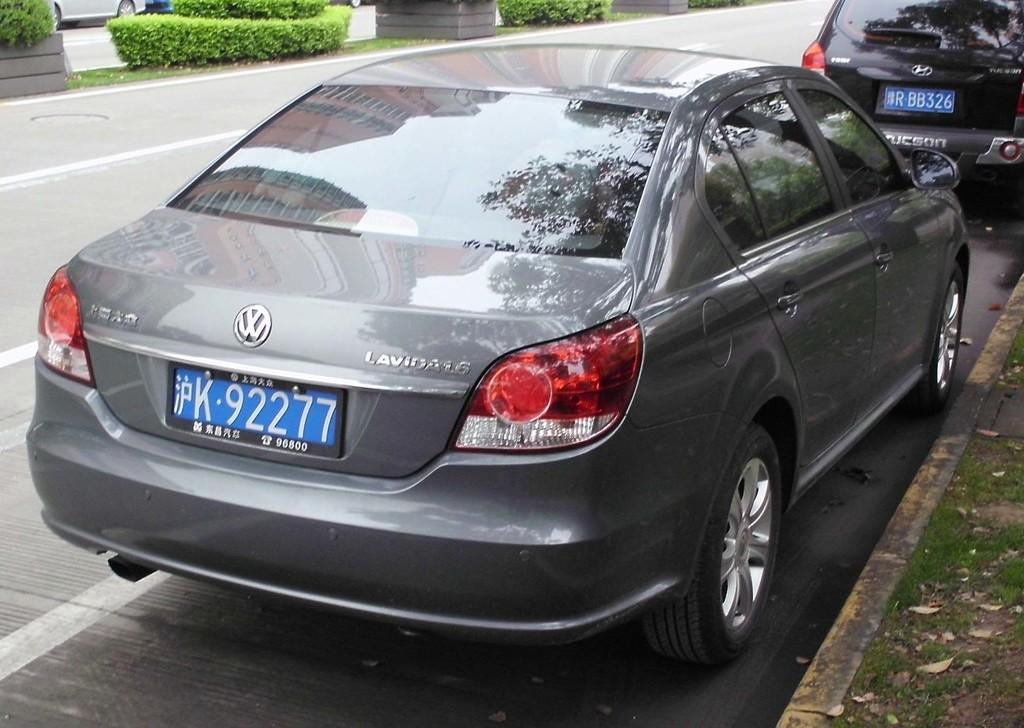<image>
Write a terse but informative summary of the picture. A VW Lavida is parked on a the right side of a street. 